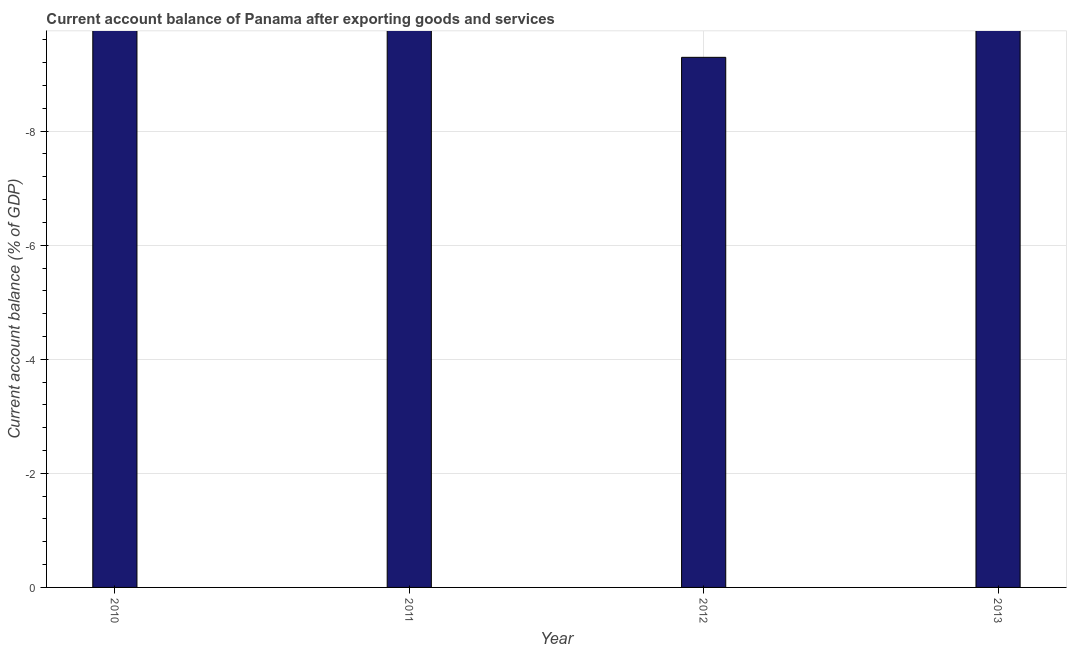Does the graph contain any zero values?
Give a very brief answer. Yes. What is the title of the graph?
Ensure brevity in your answer.  Current account balance of Panama after exporting goods and services. What is the label or title of the Y-axis?
Ensure brevity in your answer.  Current account balance (% of GDP). Across all years, what is the minimum current account balance?
Offer a terse response. 0. What is the sum of the current account balance?
Your answer should be compact. 0. What is the average current account balance per year?
Ensure brevity in your answer.  0. What is the median current account balance?
Keep it short and to the point. 0. In how many years, is the current account balance greater than the average current account balance taken over all years?
Your answer should be very brief. 0. How many bars are there?
Offer a very short reply. 0. Are all the bars in the graph horizontal?
Offer a very short reply. No. How many years are there in the graph?
Offer a very short reply. 4. What is the difference between two consecutive major ticks on the Y-axis?
Give a very brief answer. 2. What is the Current account balance (% of GDP) in 2010?
Give a very brief answer. 0. What is the Current account balance (% of GDP) of 2011?
Provide a short and direct response. 0. 